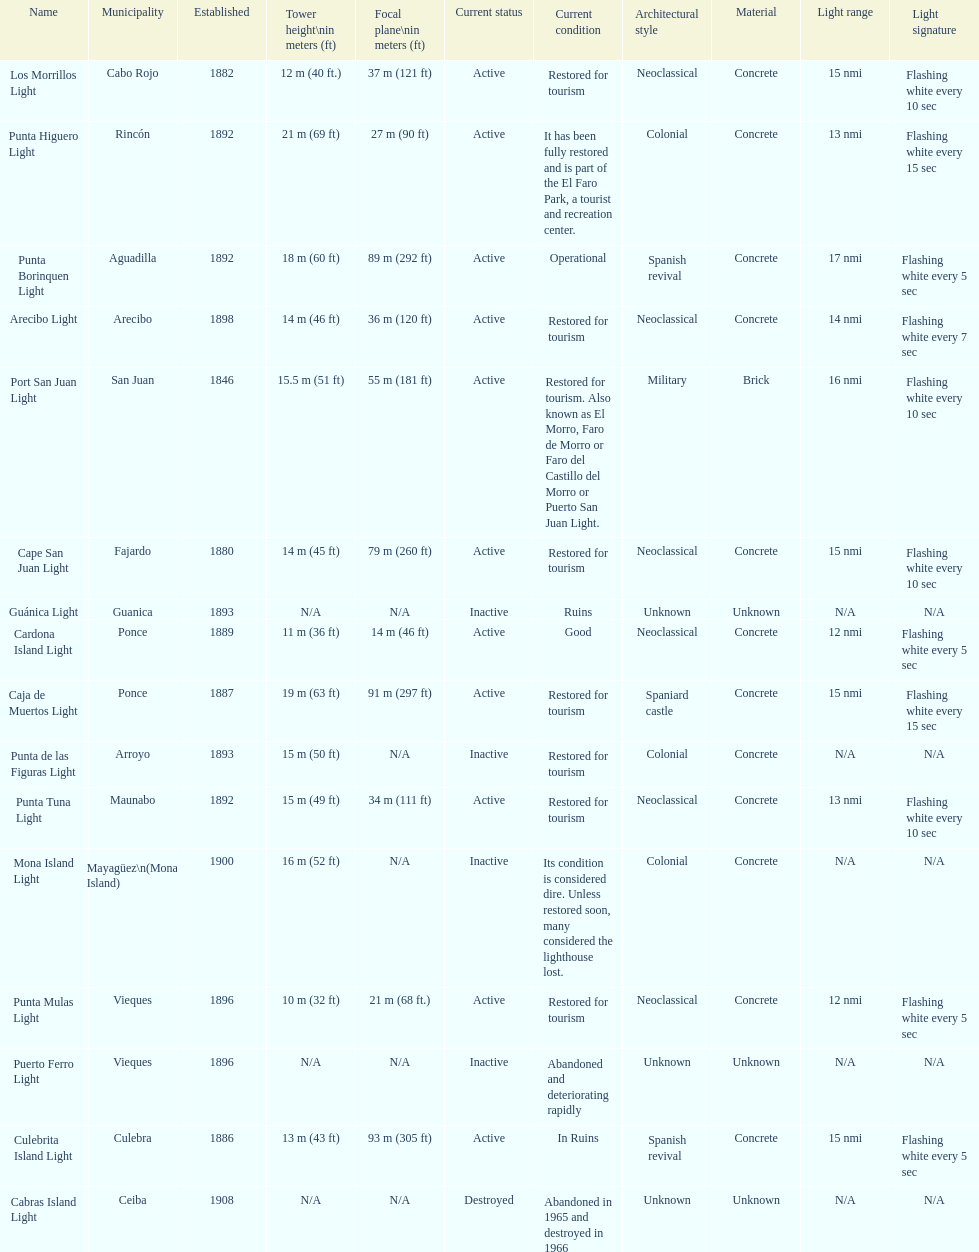Names of municipalities established before 1880 San Juan. 